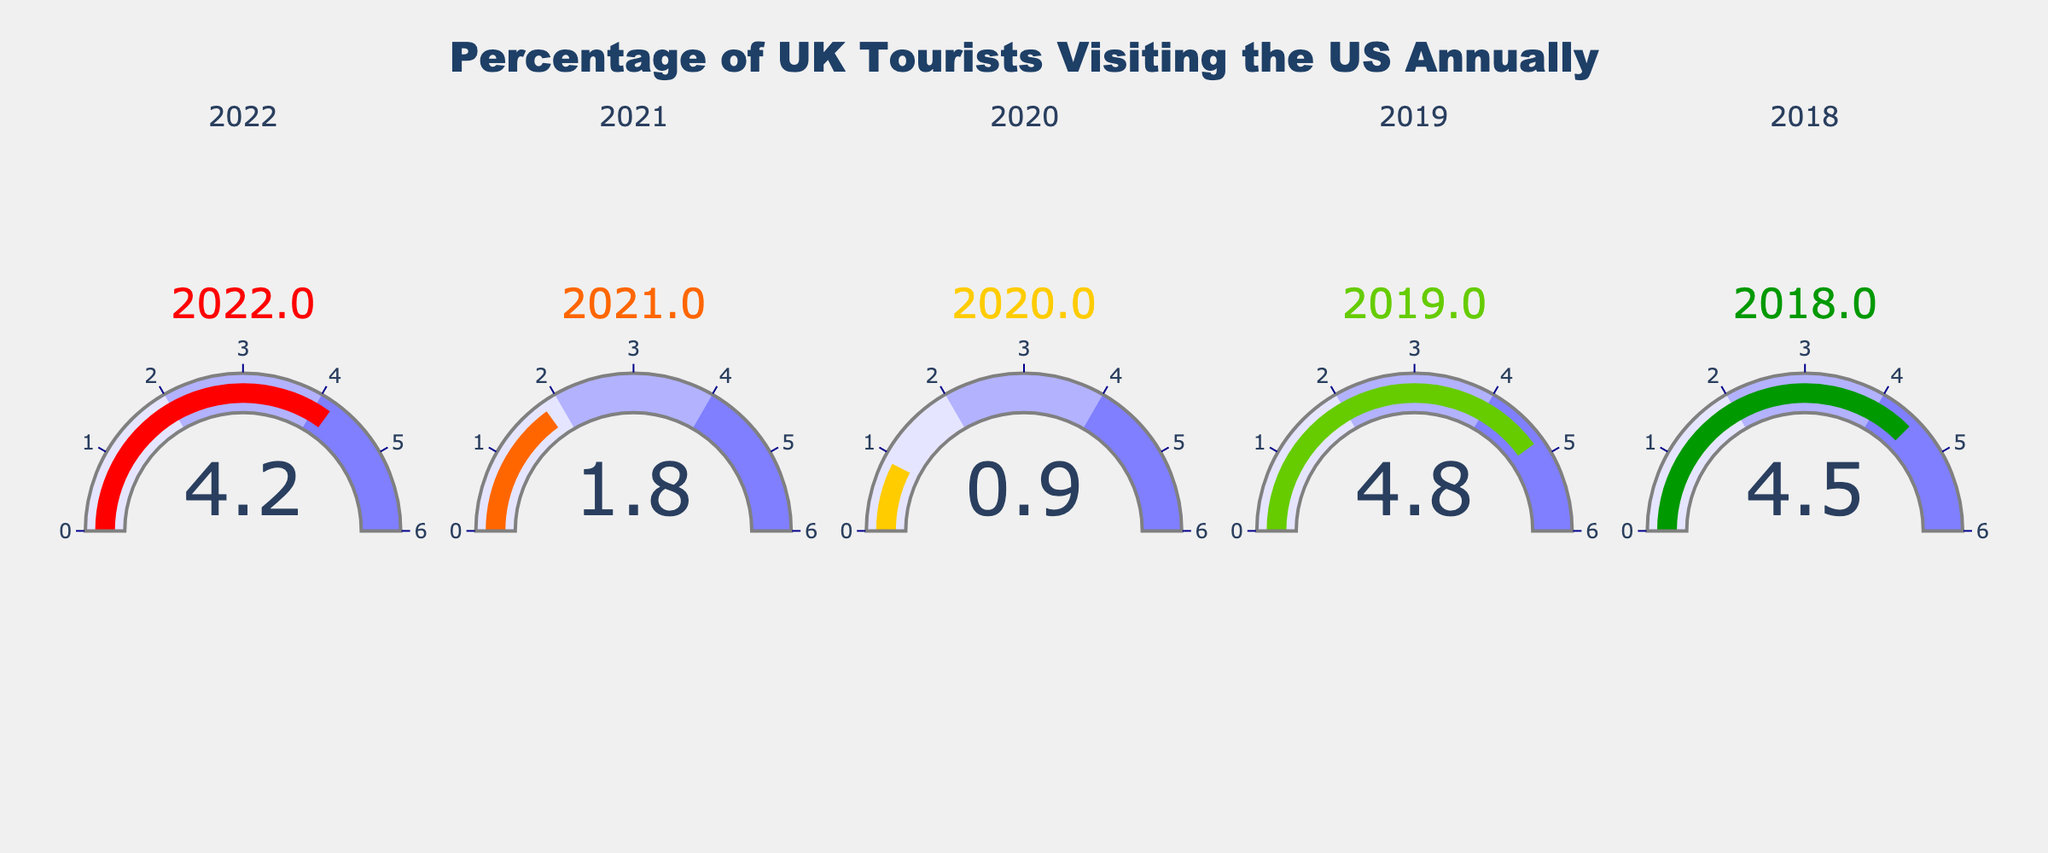How many years are displayed on the figure? The figure shows 2022, 2021, 2020, 2019, and 2018. Counting these, the number of years displayed is 5.
Answer: 5 Which year had the highest percentage of UK tourists visiting the US according to the figure? The figure shows the highest percentage at 4.8% for the year 2019.
Answer: 2019 What's the average percentage of UK tourists visiting the US over the displayed years? The percentages for 2022, 2021, 2020, 2019, and 2018 are 4.2, 1.8, 0.9, 4.8, and 4.5 respectively. Sum them up (4.2 + 1.8 + 0.9 + 4.8 + 4.5 = 16.2) and then divide by the number of years (5) to get the average (16.2/5 = 3.24).
Answer: 3.24 Which year had the lowest percentage of UK tourists visiting the US? The figure shows the lowest percentage at 0.9% for the year 2020.
Answer: 2020 What is the difference in percentage between the year with the highest and the lowest UK tourists visiting the US? The highest percentage is 4.8% in 2019, and the lowest is 0.9% in 2020. The difference is 4.8 - 0.9 = 3.9.
Answer: 3.9 How many years have a percentage of UK tourists visiting the US greater than 4%? According to the figure, the years 2022 (4.2%), 2019 (4.8%), and 2018 (4.5%) all have percentages greater than 4%.
Answer: 3 What's the median value of the percentages from the displayed years? The percentages are 4.2, 1.8, 0.9, 4.8, and 4.5. When ordered (0.9, 1.8, 4.2, 4.5, 4.8), the median value is the middle number, which is 4.2.
Answer: 4.2 